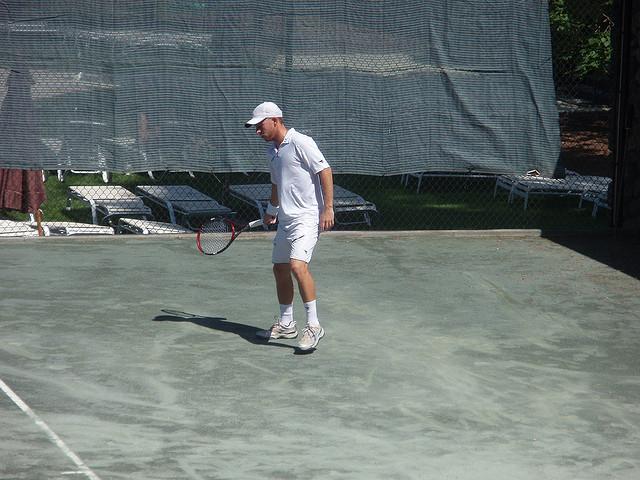How many hats are being worn backwards?
Give a very brief answer. 0. What color is the his shirt?
Be succinct. White. Is anyone sunbathing?
Concise answer only. No. What is he holding?
Concise answer only. Tennis racket. Is that Tiger Woods?
Answer briefly. No. What is the fence made of?
Write a very short answer. Chain link. What sport are the people playing?
Concise answer only. Tennis. 